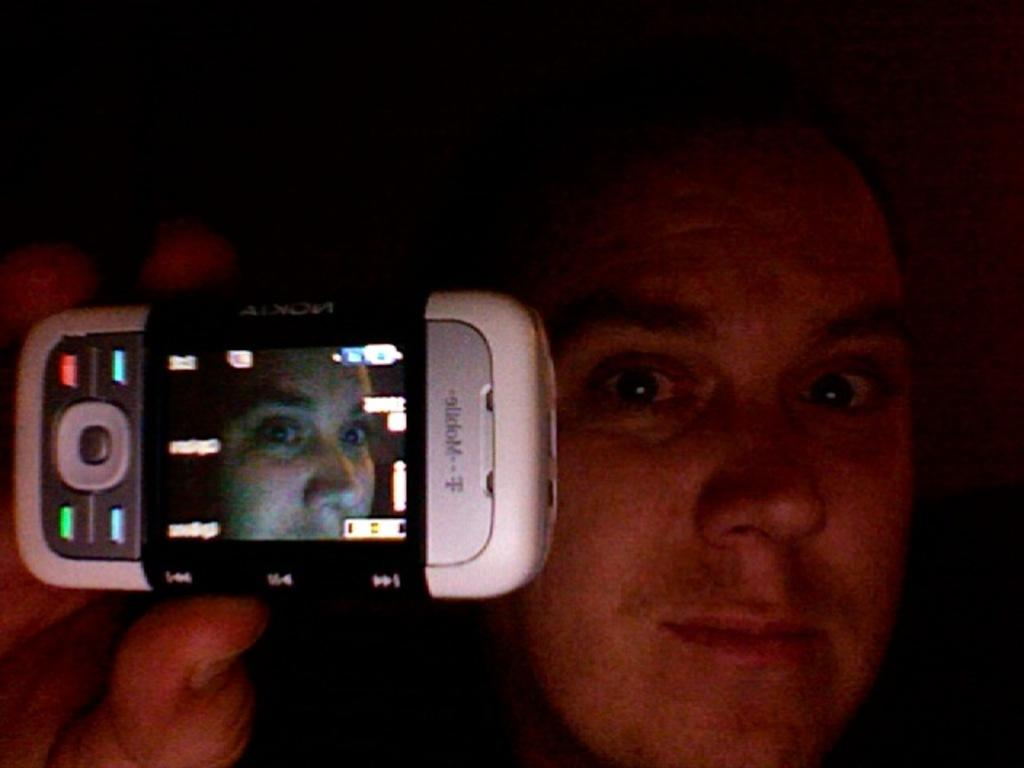What is the main subject of the image? The main subject of the image is a man. What is the man holding in the image? The man is holding a mobile in the image. What is the name of the sofa in the image? There is no sofa present in the image, so it is not possible to determine its name. 